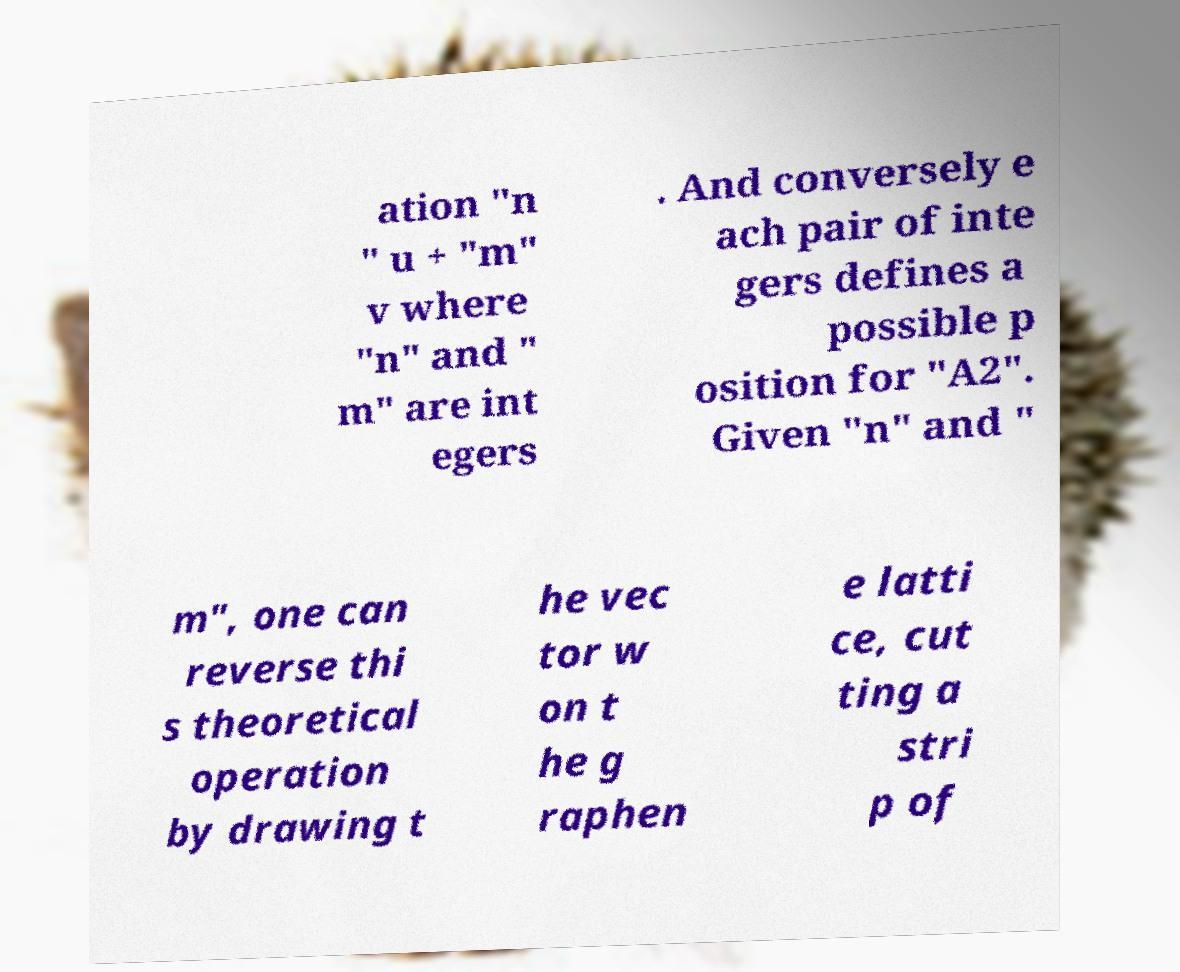There's text embedded in this image that I need extracted. Can you transcribe it verbatim? ation "n " u + "m" v where "n" and " m" are int egers . And conversely e ach pair of inte gers defines a possible p osition for "A2". Given "n" and " m", one can reverse thi s theoretical operation by drawing t he vec tor w on t he g raphen e latti ce, cut ting a stri p of 